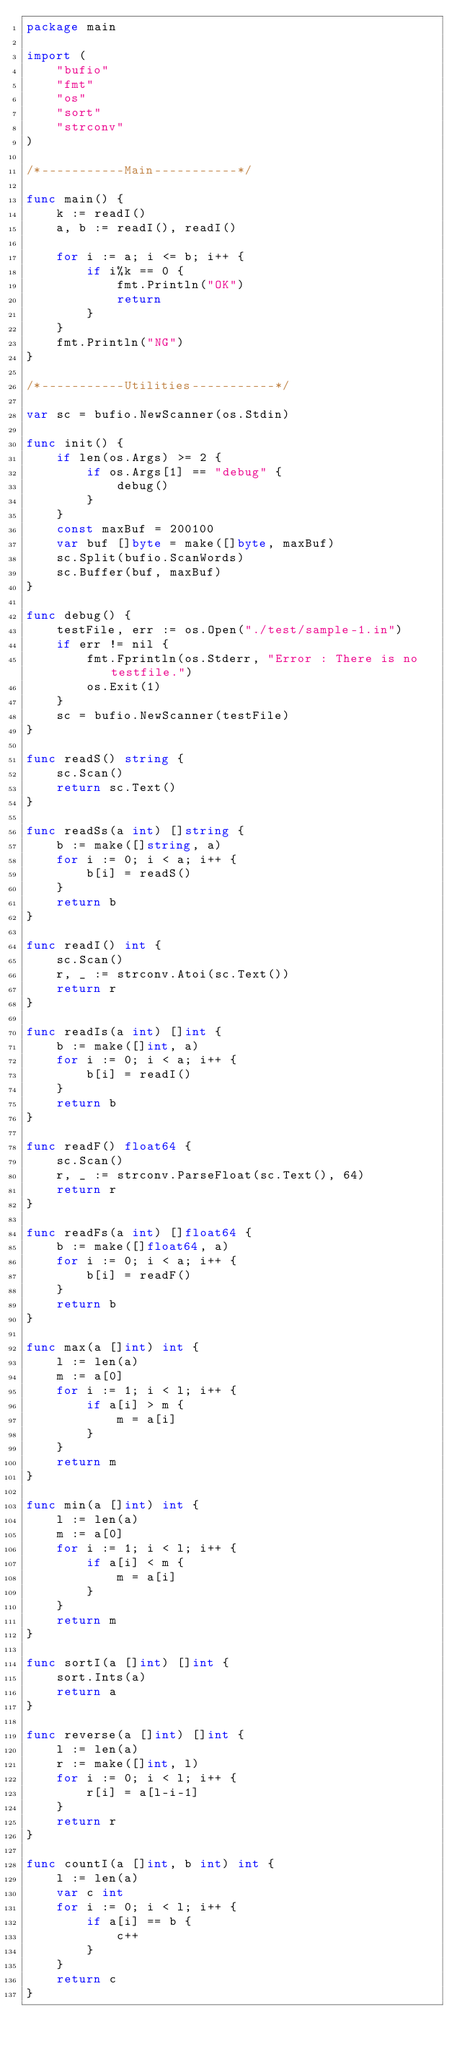<code> <loc_0><loc_0><loc_500><loc_500><_Go_>package main

import (
	"bufio"
	"fmt"
	"os"
	"sort"
	"strconv"
)

/*-----------Main-----------*/

func main() {
	k := readI()
	a, b := readI(), readI()

	for i := a; i <= b; i++ {
		if i%k == 0 {
			fmt.Println("OK")
			return
		}
	}
	fmt.Println("NG")
}

/*-----------Utilities-----------*/

var sc = bufio.NewScanner(os.Stdin)

func init() {
	if len(os.Args) >= 2 {
		if os.Args[1] == "debug" {
			debug()
		}
	}
	const maxBuf = 200100
	var buf []byte = make([]byte, maxBuf)
	sc.Split(bufio.ScanWords)
	sc.Buffer(buf, maxBuf)
}

func debug() {
	testFile, err := os.Open("./test/sample-1.in")
	if err != nil {
		fmt.Fprintln(os.Stderr, "Error : There is no testfile.")
		os.Exit(1)
	}
	sc = bufio.NewScanner(testFile)
}

func readS() string {
	sc.Scan()
	return sc.Text()
}

func readSs(a int) []string {
	b := make([]string, a)
	for i := 0; i < a; i++ {
		b[i] = readS()
	}
	return b
}

func readI() int {
	sc.Scan()
	r, _ := strconv.Atoi(sc.Text())
	return r
}

func readIs(a int) []int {
	b := make([]int, a)
	for i := 0; i < a; i++ {
		b[i] = readI()
	}
	return b
}

func readF() float64 {
	sc.Scan()
	r, _ := strconv.ParseFloat(sc.Text(), 64)
	return r
}

func readFs(a int) []float64 {
	b := make([]float64, a)
	for i := 0; i < a; i++ {
		b[i] = readF()
	}
	return b
}

func max(a []int) int {
	l := len(a)
	m := a[0]
	for i := 1; i < l; i++ {
		if a[i] > m {
			m = a[i]
		}
	}
	return m
}

func min(a []int) int {
	l := len(a)
	m := a[0]
	for i := 1; i < l; i++ {
		if a[i] < m {
			m = a[i]
		}
	}
	return m
}

func sortI(a []int) []int {
	sort.Ints(a)
	return a
}

func reverse(a []int) []int {
	l := len(a)
	r := make([]int, l)
	for i := 0; i < l; i++ {
		r[i] = a[l-i-1]
	}
	return r
}

func countI(a []int, b int) int {
	l := len(a)
	var c int
	for i := 0; i < l; i++ {
		if a[i] == b {
			c++
		}
	}
	return c
}
</code> 